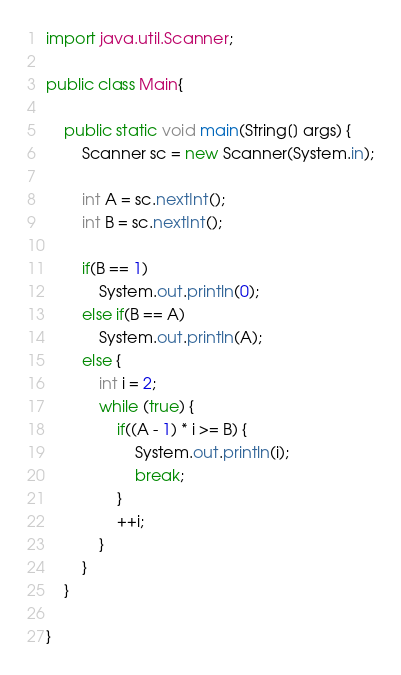<code> <loc_0><loc_0><loc_500><loc_500><_Java_>

import java.util.Scanner;

public class Main{

    public static void main(String[] args) {
        Scanner sc = new Scanner(System.in);

        int A = sc.nextInt();
        int B = sc.nextInt();

        if(B == 1) 
            System.out.println(0);
        else if(B == A)
        	System.out.println(A);
        else {
			int i = 2;
			while (true) {
				if((A - 1) * i >= B) {
					System.out.println(i);
					break;
				}
				++i;
			}
		}
    }

}
</code> 